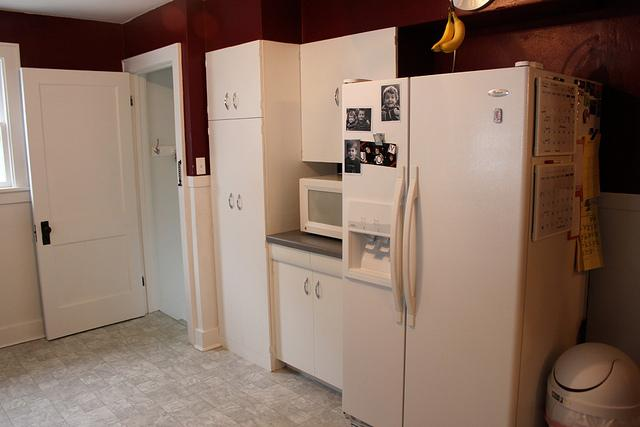What is on the side of the refrigerator?

Choices:
A) dog
B) laundry basket
C) cat
D) garbage disposal garbage disposal 